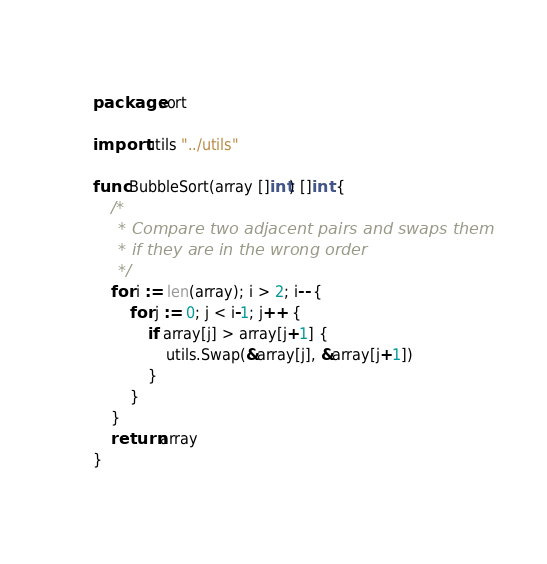<code> <loc_0><loc_0><loc_500><loc_500><_Go_>package sort

import utils "../utils"

func BubbleSort(array []int) []int {
	/*
	 * Compare two adjacent pairs and swaps them
	 * if they are in the wrong order
	 */
	for i := len(array); i > 2; i-- {
		for j := 0; j < i-1; j++ {
			if array[j] > array[j+1] {
				utils.Swap(&array[j], &array[j+1])
			}
		}
	}
	return array
}
</code> 